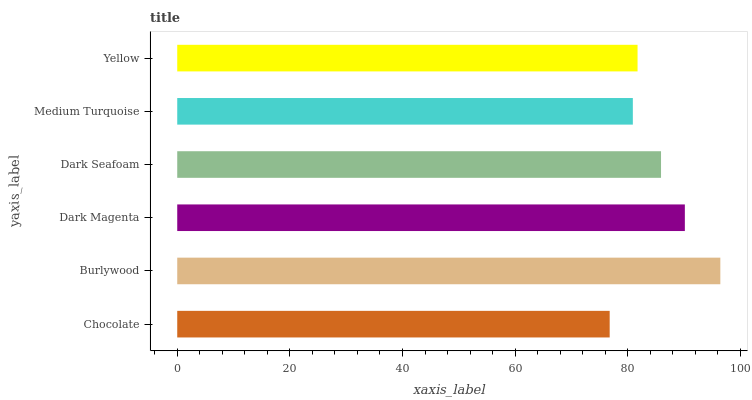Is Chocolate the minimum?
Answer yes or no. Yes. Is Burlywood the maximum?
Answer yes or no. Yes. Is Dark Magenta the minimum?
Answer yes or no. No. Is Dark Magenta the maximum?
Answer yes or no. No. Is Burlywood greater than Dark Magenta?
Answer yes or no. Yes. Is Dark Magenta less than Burlywood?
Answer yes or no. Yes. Is Dark Magenta greater than Burlywood?
Answer yes or no. No. Is Burlywood less than Dark Magenta?
Answer yes or no. No. Is Dark Seafoam the high median?
Answer yes or no. Yes. Is Yellow the low median?
Answer yes or no. Yes. Is Burlywood the high median?
Answer yes or no. No. Is Chocolate the low median?
Answer yes or no. No. 